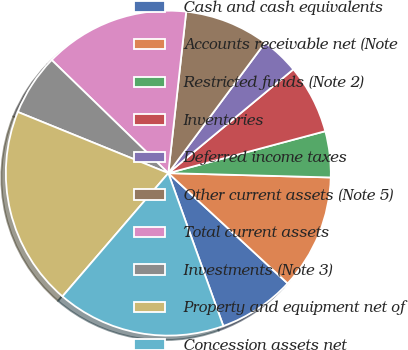<chart> <loc_0><loc_0><loc_500><loc_500><pie_chart><fcel>Cash and cash equivalents<fcel>Accounts receivable net (Note<fcel>Restricted funds (Note 2)<fcel>Inventories<fcel>Deferred income taxes<fcel>Other current assets (Note 5)<fcel>Total current assets<fcel>Investments (Note 3)<fcel>Property and equipment net of<fcel>Concession assets net<nl><fcel>7.63%<fcel>11.45%<fcel>4.58%<fcel>6.87%<fcel>3.82%<fcel>8.4%<fcel>14.5%<fcel>6.11%<fcel>19.85%<fcel>16.79%<nl></chart> 